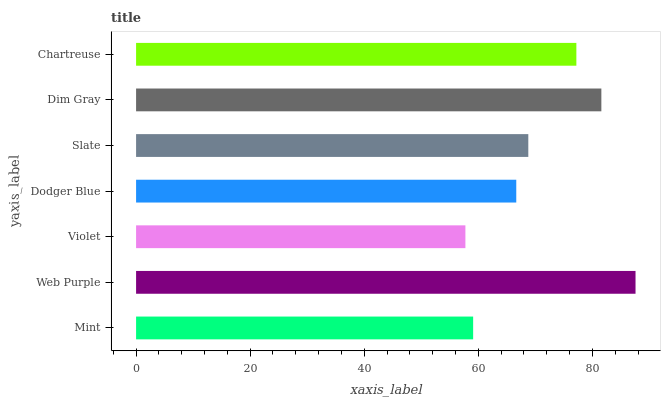Is Violet the minimum?
Answer yes or no. Yes. Is Web Purple the maximum?
Answer yes or no. Yes. Is Web Purple the minimum?
Answer yes or no. No. Is Violet the maximum?
Answer yes or no. No. Is Web Purple greater than Violet?
Answer yes or no. Yes. Is Violet less than Web Purple?
Answer yes or no. Yes. Is Violet greater than Web Purple?
Answer yes or no. No. Is Web Purple less than Violet?
Answer yes or no. No. Is Slate the high median?
Answer yes or no. Yes. Is Slate the low median?
Answer yes or no. Yes. Is Mint the high median?
Answer yes or no. No. Is Violet the low median?
Answer yes or no. No. 